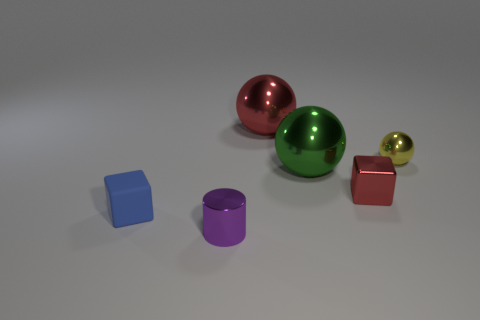How many other things are the same shape as the small blue object? The small blue object is a cube, and there is one other cube in the image, which is colored red. Therefore, there is just one other object that shares the same cube shape. 